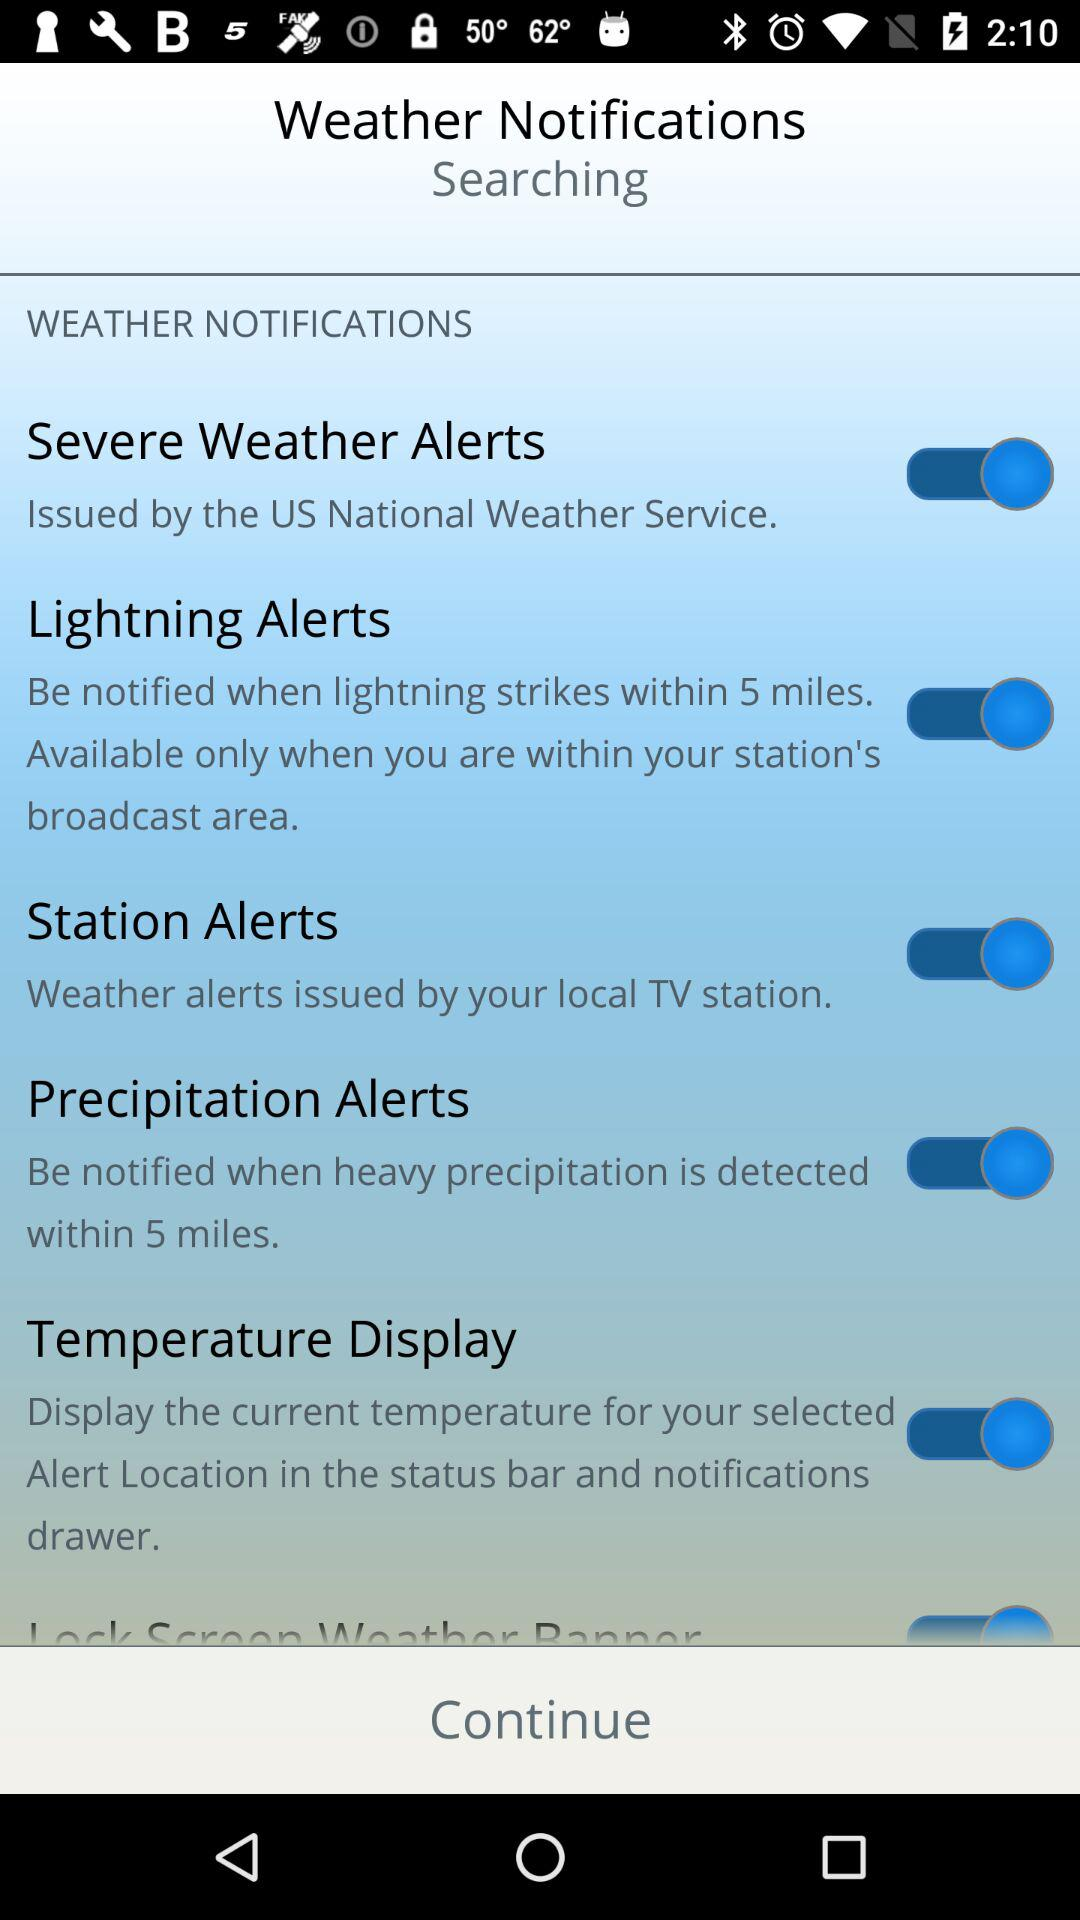Where is the current temperature displayed? The current temperature is displayed "in the status bar and notifications drawer". 